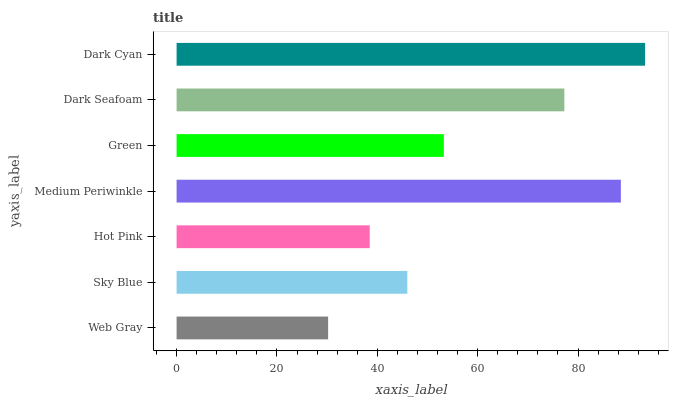Is Web Gray the minimum?
Answer yes or no. Yes. Is Dark Cyan the maximum?
Answer yes or no. Yes. Is Sky Blue the minimum?
Answer yes or no. No. Is Sky Blue the maximum?
Answer yes or no. No. Is Sky Blue greater than Web Gray?
Answer yes or no. Yes. Is Web Gray less than Sky Blue?
Answer yes or no. Yes. Is Web Gray greater than Sky Blue?
Answer yes or no. No. Is Sky Blue less than Web Gray?
Answer yes or no. No. Is Green the high median?
Answer yes or no. Yes. Is Green the low median?
Answer yes or no. Yes. Is Web Gray the high median?
Answer yes or no. No. Is Sky Blue the low median?
Answer yes or no. No. 